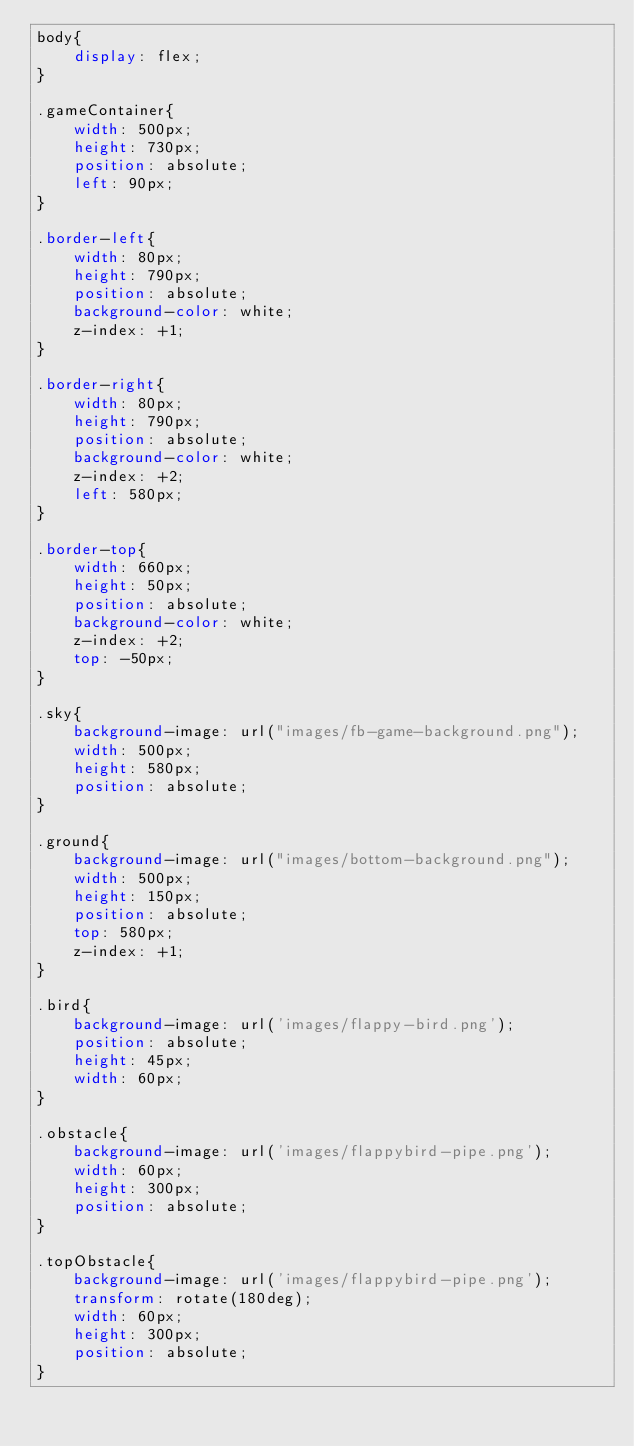Convert code to text. <code><loc_0><loc_0><loc_500><loc_500><_CSS_>body{
    display: flex;
}

.gameContainer{
    width: 500px;
    height: 730px;
    position: absolute;
    left: 90px;
}

.border-left{
    width: 80px;
    height: 790px;
    position: absolute;
    background-color: white;
    z-index: +1;
}

.border-right{
    width: 80px;
    height: 790px;
    position: absolute;
    background-color: white;
    z-index: +2;
    left: 580px;
}

.border-top{
    width: 660px;
    height: 50px;
    position: absolute;
    background-color: white;
    z-index: +2;
    top: -50px;
}

.sky{
    background-image: url("images/fb-game-background.png");
    width: 500px;
    height: 580px;
    position: absolute;
}

.ground{
    background-image: url("images/bottom-background.png");
    width: 500px;
    height: 150px;
    position: absolute;
    top: 580px;
    z-index: +1;
}

.bird{
    background-image: url('images/flappy-bird.png');
    position: absolute;
    height: 45px;
    width: 60px;
}

.obstacle{
    background-image: url('images/flappybird-pipe.png');
    width: 60px;
    height: 300px;
    position: absolute;
}

.topObstacle{
    background-image: url('images/flappybird-pipe.png');
    transform: rotate(180deg); 
    width: 60px;
    height: 300px;
    position: absolute;
}</code> 